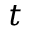<formula> <loc_0><loc_0><loc_500><loc_500>t</formula> 